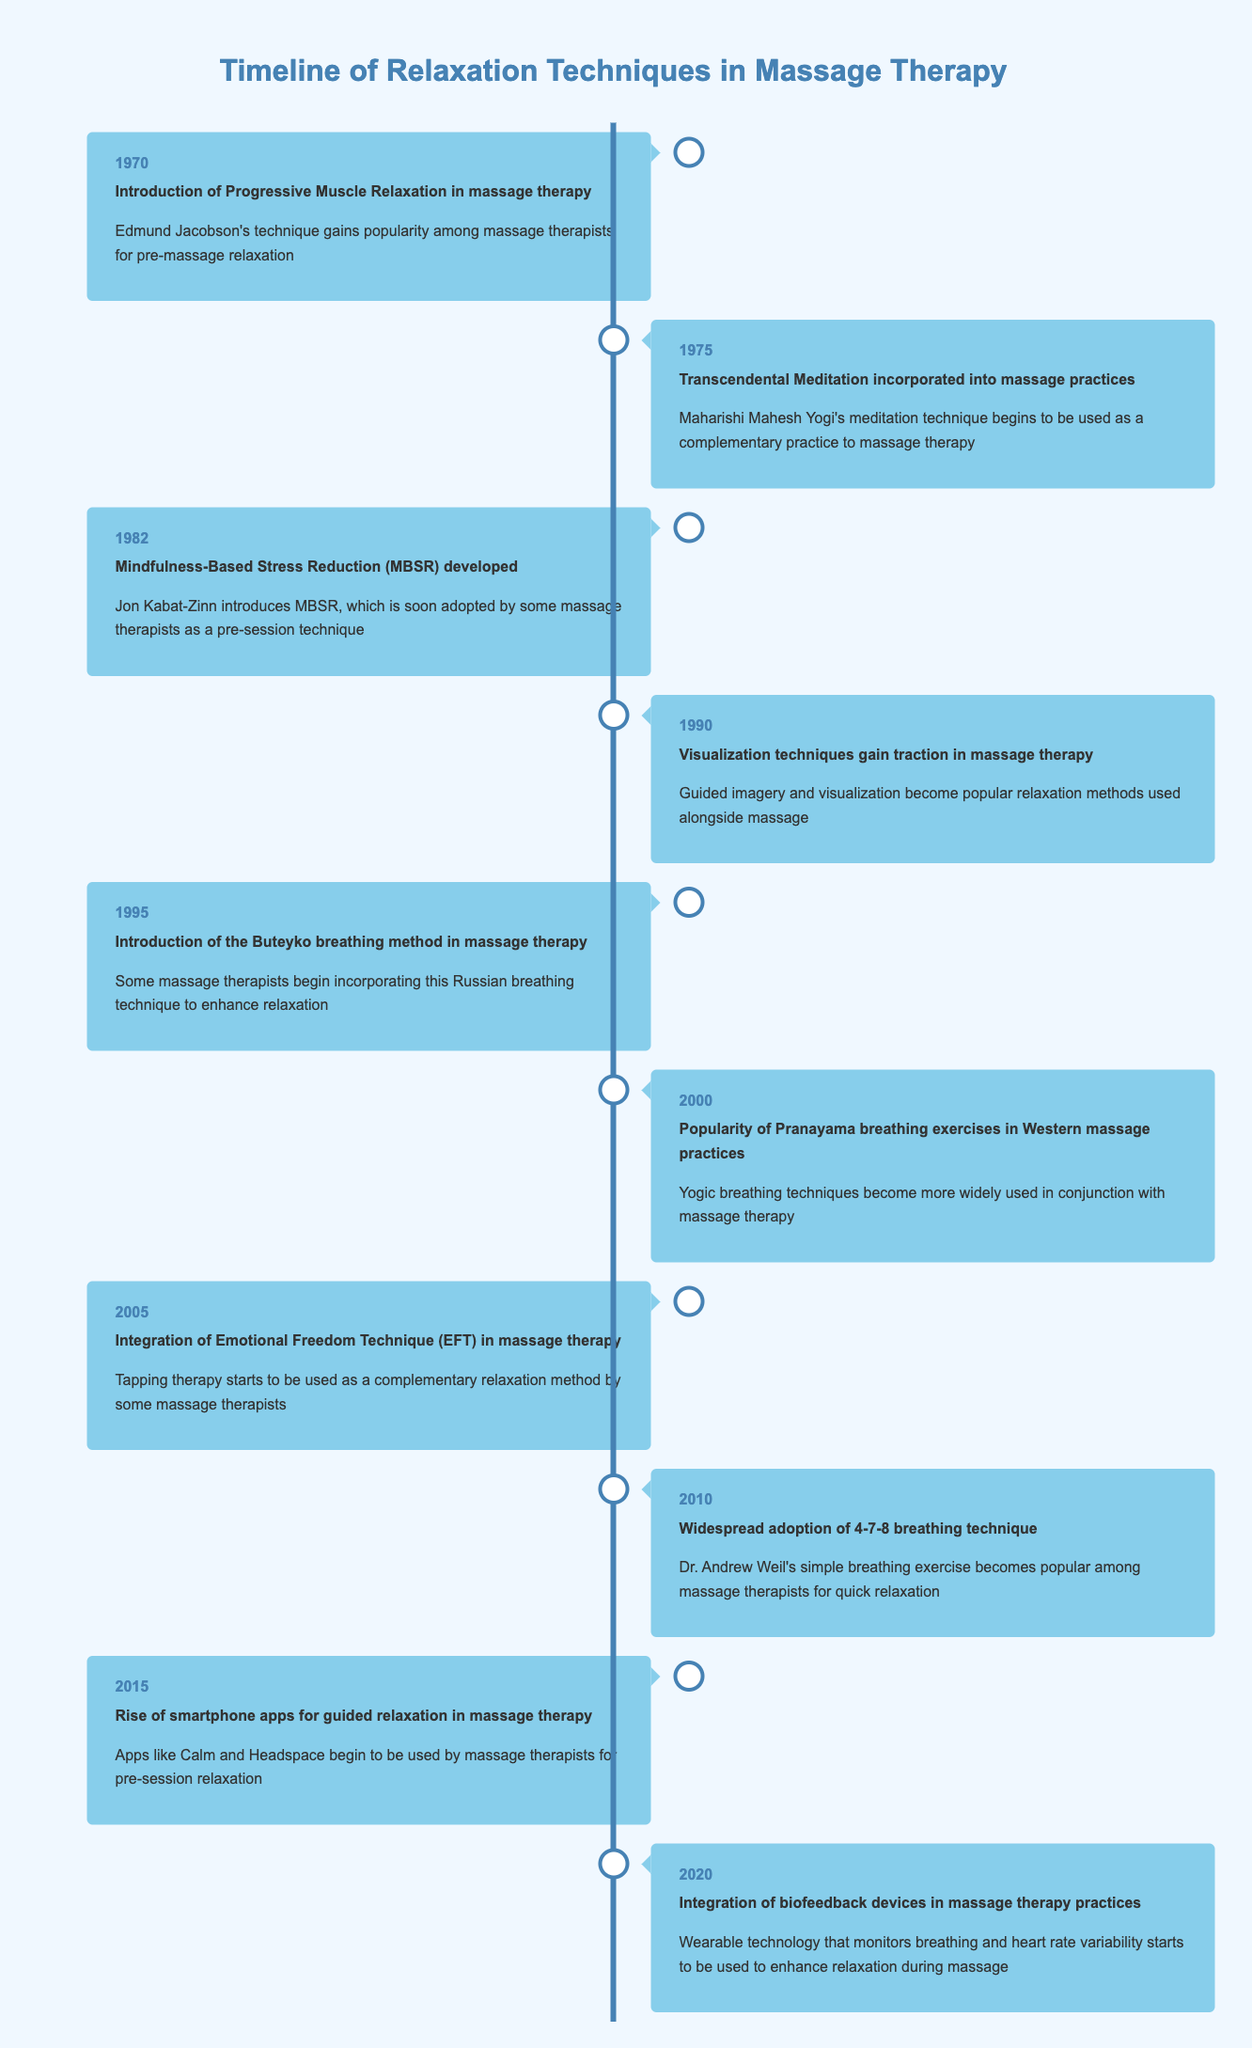What year was the Integration of Emotional Freedom Technique (EFT) introduced in massage therapy? The event "Integration of Emotional Freedom Technique (EFT) in massage therapy" occurred in the year 2005.
Answer: 2005 Which relaxation technique was introduced in massage therapy first, Progressive Muscle Relaxation or Transcendental Meditation? Progressive Muscle Relaxation was introduced in 1970, while Transcendental Meditation was incorporated in 1975. Therefore, Progressive Muscle Relaxation came first.
Answer: Progressive Muscle Relaxation How many years are between the introduction of the Buteyko breathing method and the widespread adoption of the 4-7-8 breathing technique? The Buteyko breathing method was introduced in 1995, and the 4-7-8 breathing technique was adopted in 2010. The difference between these years is 2010 - 1995 = 15 years.
Answer: 15 Did the popularity of Pranayama breathing exercises occur before or after the development of Mindfulness-Based Stress Reduction? The popularity of Pranayama breathing exercises occurred in 2000, while Mindfulness-Based Stress Reduction was developed in 1982. Thus, Pranayama breathing exercises became popular after MBSR.
Answer: After In which year did the integration of biofeedback devices in massage practices occur, and what preceding technique was adopted in 2015? The integration of biofeedback devices occurred in 2020 and the preceding technique adopted in 2015 was the rise of smartphone apps for guided relaxation.
Answer: 2020; smartphone apps What percentage of the events in the table incorporated breathing techniques by the year 2000? There are a total of 7 events listed by 2000, out of which 3 include breathing techniques (Buteyko method, Pranayama exercises, and the 4-7-8 breathing technique). The percentage is (3/7) * 100 = approximately 42.86%.
Answer: Approximately 42.86% Was the introduction of Progressive Muscle Relaxation a significant milestone in the timeline? Yes, it was the first event in the timeline, marking the start of incorporating structured relaxation techniques into massage therapy.
Answer: Yes How many techniques were introduced between 1990 and 2010? The techniques introduced between those years are Visualization techniques (1990), the Buteyko breathing method (1995), Emotional Freedom Technique (2005), and the 4-7-8 breathing technique (2010). Therefore, 4 techniques were introduced.
Answer: 4 